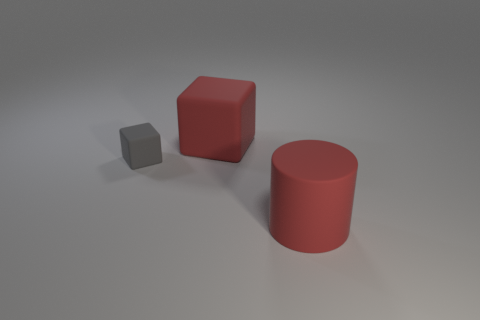Does the tiny gray matte object have the same shape as the big matte object that is left of the rubber cylinder?
Make the answer very short. Yes. Are there fewer large cylinders that are left of the gray rubber block than large blue metallic objects?
Keep it short and to the point. No. There is a red rubber cylinder; are there any red objects right of it?
Your response must be concise. No. Is there a big matte object that has the same shape as the small gray rubber thing?
Offer a very short reply. Yes. There is a red matte object that is the same size as the red cylinder; what shape is it?
Offer a very short reply. Cube. How many objects are big red rubber objects behind the gray thing or tiny red shiny objects?
Your answer should be compact. 1. Is the color of the tiny matte block the same as the big matte cube?
Provide a succinct answer. No. There is a rubber cube in front of the large red matte block; how big is it?
Ensure brevity in your answer.  Small. Are there any other matte objects that have the same size as the gray thing?
Give a very brief answer. No. Does the rubber cube right of the gray rubber object have the same size as the big rubber cylinder?
Your answer should be very brief. Yes. 